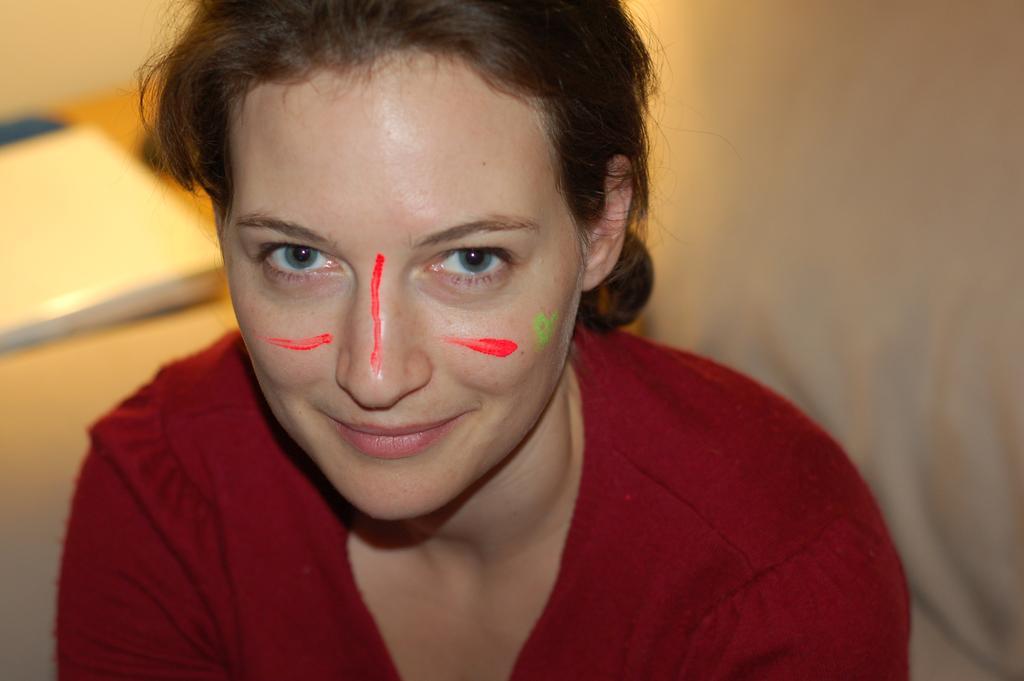Please provide a concise description of this image. In this image we can see a woman. On the woman's face we can see some color. The background of the image is blurred. 